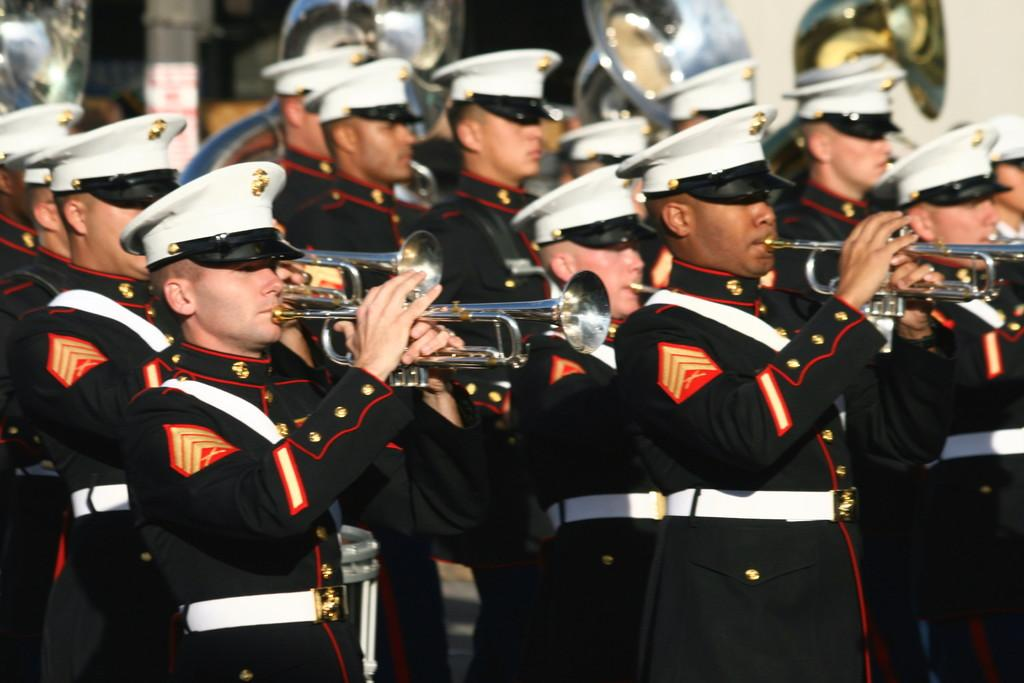Who or what can be seen in the image? There are persons in the image. What are the persons doing in the image? The persons are walking on the road. What else can be observed about the persons in the image? The persons are holding musical instruments. Can you see a hen walking alongside the persons in the image? There is no hen present in the image; it only features persons walking on the road while holding musical instruments. 